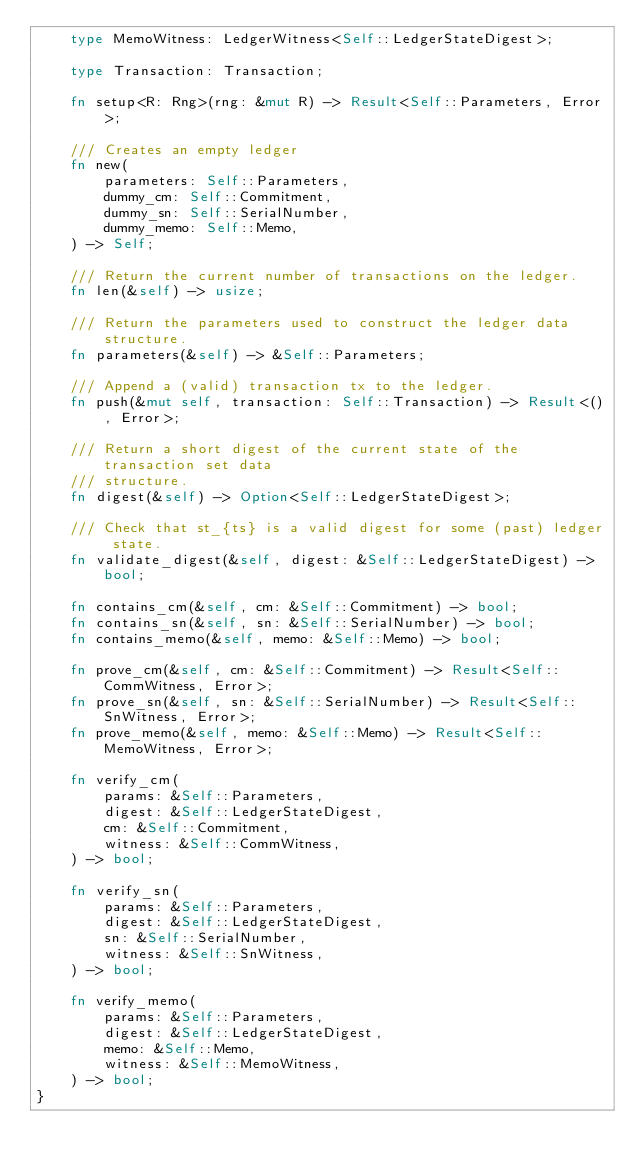<code> <loc_0><loc_0><loc_500><loc_500><_Rust_>    type MemoWitness: LedgerWitness<Self::LedgerStateDigest>;

    type Transaction: Transaction;

    fn setup<R: Rng>(rng: &mut R) -> Result<Self::Parameters, Error>;

    /// Creates an empty ledger
    fn new(
        parameters: Self::Parameters,
        dummy_cm: Self::Commitment,
        dummy_sn: Self::SerialNumber,
        dummy_memo: Self::Memo,
    ) -> Self;

    /// Return the current number of transactions on the ledger.
    fn len(&self) -> usize;

    /// Return the parameters used to construct the ledger data structure.
    fn parameters(&self) -> &Self::Parameters;

    /// Append a (valid) transaction tx to the ledger.
    fn push(&mut self, transaction: Self::Transaction) -> Result<(), Error>;

    /// Return a short digest of the current state of the transaction set data
    /// structure.
    fn digest(&self) -> Option<Self::LedgerStateDigest>;

    /// Check that st_{ts} is a valid digest for some (past) ledger state.
    fn validate_digest(&self, digest: &Self::LedgerStateDigest) -> bool;

    fn contains_cm(&self, cm: &Self::Commitment) -> bool;
    fn contains_sn(&self, sn: &Self::SerialNumber) -> bool;
    fn contains_memo(&self, memo: &Self::Memo) -> bool;

    fn prove_cm(&self, cm: &Self::Commitment) -> Result<Self::CommWitness, Error>;
    fn prove_sn(&self, sn: &Self::SerialNumber) -> Result<Self::SnWitness, Error>;
    fn prove_memo(&self, memo: &Self::Memo) -> Result<Self::MemoWitness, Error>;

    fn verify_cm(
        params: &Self::Parameters,
        digest: &Self::LedgerStateDigest,
        cm: &Self::Commitment,
        witness: &Self::CommWitness,
    ) -> bool;

    fn verify_sn(
        params: &Self::Parameters,
        digest: &Self::LedgerStateDigest,
        sn: &Self::SerialNumber,
        witness: &Self::SnWitness,
    ) -> bool;

    fn verify_memo(
        params: &Self::Parameters,
        digest: &Self::LedgerStateDigest,
        memo: &Self::Memo,
        witness: &Self::MemoWitness,
    ) -> bool;
}
</code> 